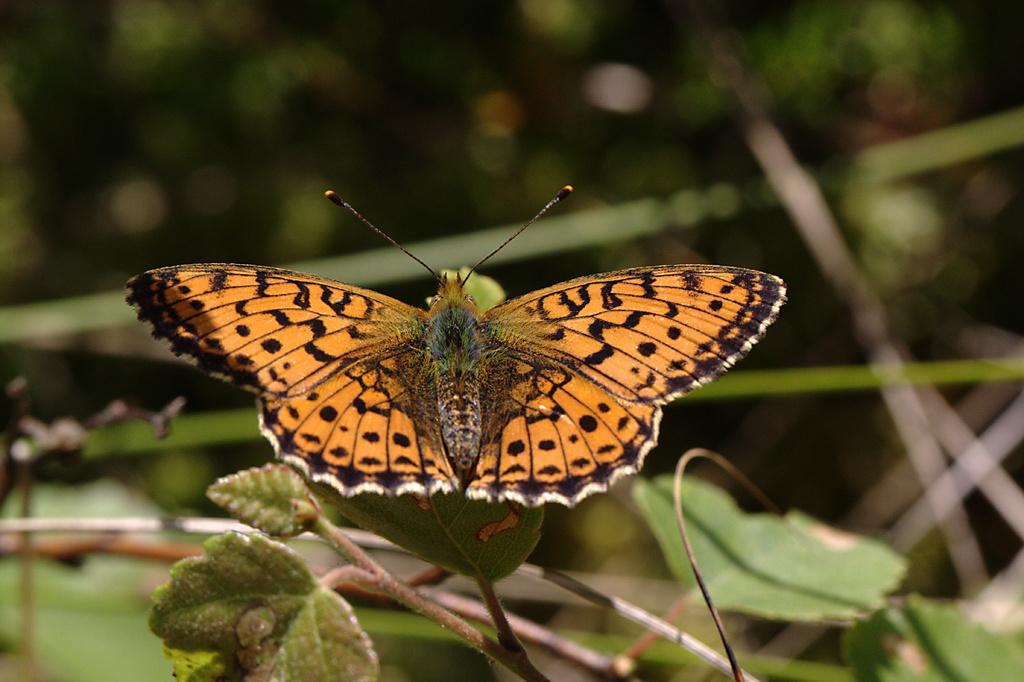What type of insect is present in the image? There is an orange color butterfly in the image. Where is the butterfly located? The butterfly is on plant leaves. Can you describe the background of the image? The background of the image is blurred. What type of humor does the creator of the image use in the school setting? There is no information about the creator of the image or a school setting in the provided facts, so it is not possible to answer this question. 